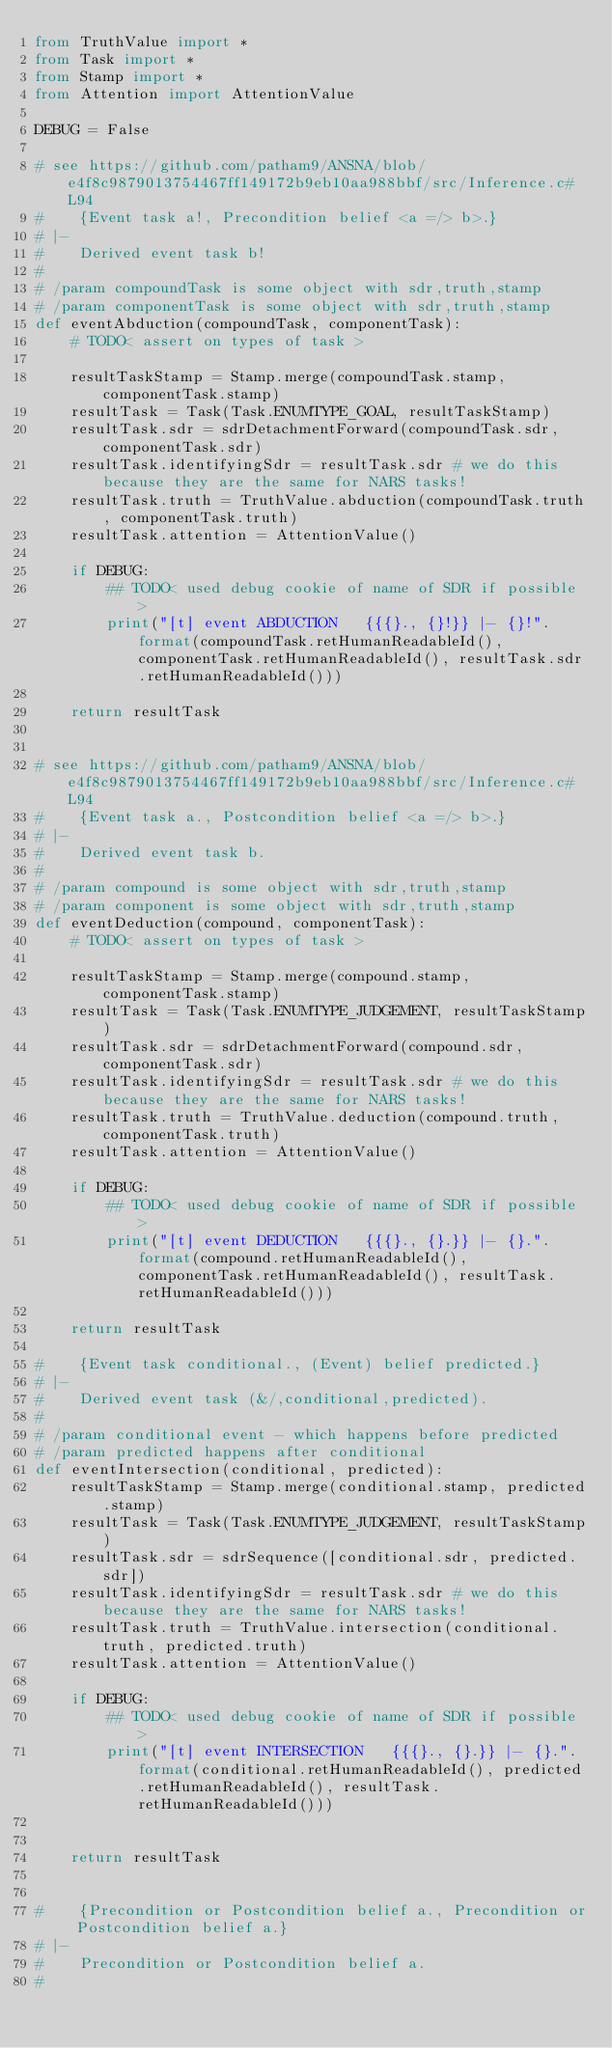<code> <loc_0><loc_0><loc_500><loc_500><_Python_>from TruthValue import *
from Task import *
from Stamp import *
from Attention import AttentionValue

DEBUG = False

# see https://github.com/patham9/ANSNA/blob/e4f8c9879013754467ff149172b9eb10aa988bbf/src/Inference.c#L94
#    {Event task a!, Precondition belief <a =/> b>.}
# |-
#    Derived event task b!
#
# /param compoundTask is some object with sdr,truth,stamp
# /param componentTask is some object with sdr,truth,stamp
def eventAbduction(compoundTask, componentTask):
    # TODO< assert on types of task >

    resultTaskStamp = Stamp.merge(compoundTask.stamp, componentTask.stamp)
    resultTask = Task(Task.ENUMTYPE_GOAL, resultTaskStamp)
    resultTask.sdr = sdrDetachmentForward(compoundTask.sdr, componentTask.sdr)
    resultTask.identifyingSdr = resultTask.sdr # we do this because they are the same for NARS tasks!
    resultTask.truth = TruthValue.abduction(compoundTask.truth, componentTask.truth)
    resultTask.attention = AttentionValue()

    if DEBUG:
        ## TODO< used debug cookie of name of SDR if possible >
        print("[t] event ABDUCTION   {{{}., {}!}} |- {}!".format(compoundTask.retHumanReadableId(), componentTask.retHumanReadableId(), resultTask.sdr.retHumanReadableId()))

    return resultTask


# see https://github.com/patham9/ANSNA/blob/e4f8c9879013754467ff149172b9eb10aa988bbf/src/Inference.c#L94
#    {Event task a., Postcondition belief <a =/> b>.}
# |-
#    Derived event task b.
#
# /param compound is some object with sdr,truth,stamp
# /param component is some object with sdr,truth,stamp
def eventDeduction(compound, componentTask):
    # TODO< assert on types of task >

    resultTaskStamp = Stamp.merge(compound.stamp, componentTask.stamp)
    resultTask = Task(Task.ENUMTYPE_JUDGEMENT, resultTaskStamp)
    resultTask.sdr = sdrDetachmentForward(compound.sdr, componentTask.sdr)
    resultTask.identifyingSdr = resultTask.sdr # we do this because they are the same for NARS tasks!
    resultTask.truth = TruthValue.deduction(compound.truth, componentTask.truth)
    resultTask.attention = AttentionValue()

    if DEBUG:
        ## TODO< used debug cookie of name of SDR if possible >
        print("[t] event DEDUCTION   {{{}., {}.}} |- {}.".format(compound.retHumanReadableId(), componentTask.retHumanReadableId(), resultTask.retHumanReadableId()))

    return resultTask

#    {Event task conditional., (Event) belief predicted.}
# |-
#    Derived event task (&/,conditional,predicted).
#
# /param conditional event - which happens before predicted
# /param predicted happens after conditional
def eventIntersection(conditional, predicted):
    resultTaskStamp = Stamp.merge(conditional.stamp, predicted.stamp)
    resultTask = Task(Task.ENUMTYPE_JUDGEMENT, resultTaskStamp)
    resultTask.sdr = sdrSequence([conditional.sdr, predicted.sdr])
    resultTask.identifyingSdr = resultTask.sdr # we do this because they are the same for NARS tasks!
    resultTask.truth = TruthValue.intersection(conditional.truth, predicted.truth)
    resultTask.attention = AttentionValue()

    if DEBUG:
        ## TODO< used debug cookie of name of SDR if possible >
        print("[t] event INTERSECTION   {{{}., {}.}} |- {}.".format(conditional.retHumanReadableId(), predicted.retHumanReadableId(), resultTask.retHumanReadableId()))


    return resultTask


#    {Precondition or Postcondition belief a., Precondition or Postcondition belief a.}
# |- 
#    Precondition or Postcondition belief a.
#</code> 